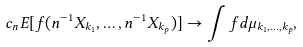Convert formula to latex. <formula><loc_0><loc_0><loc_500><loc_500>c _ { n } E [ f ( n ^ { - 1 } X _ { k _ { 1 } } , \dots , n ^ { - 1 } X _ { k _ { p } } ) ] \to \int f d \mu _ { k _ { 1 } , \dots , k _ { p } } ,</formula> 